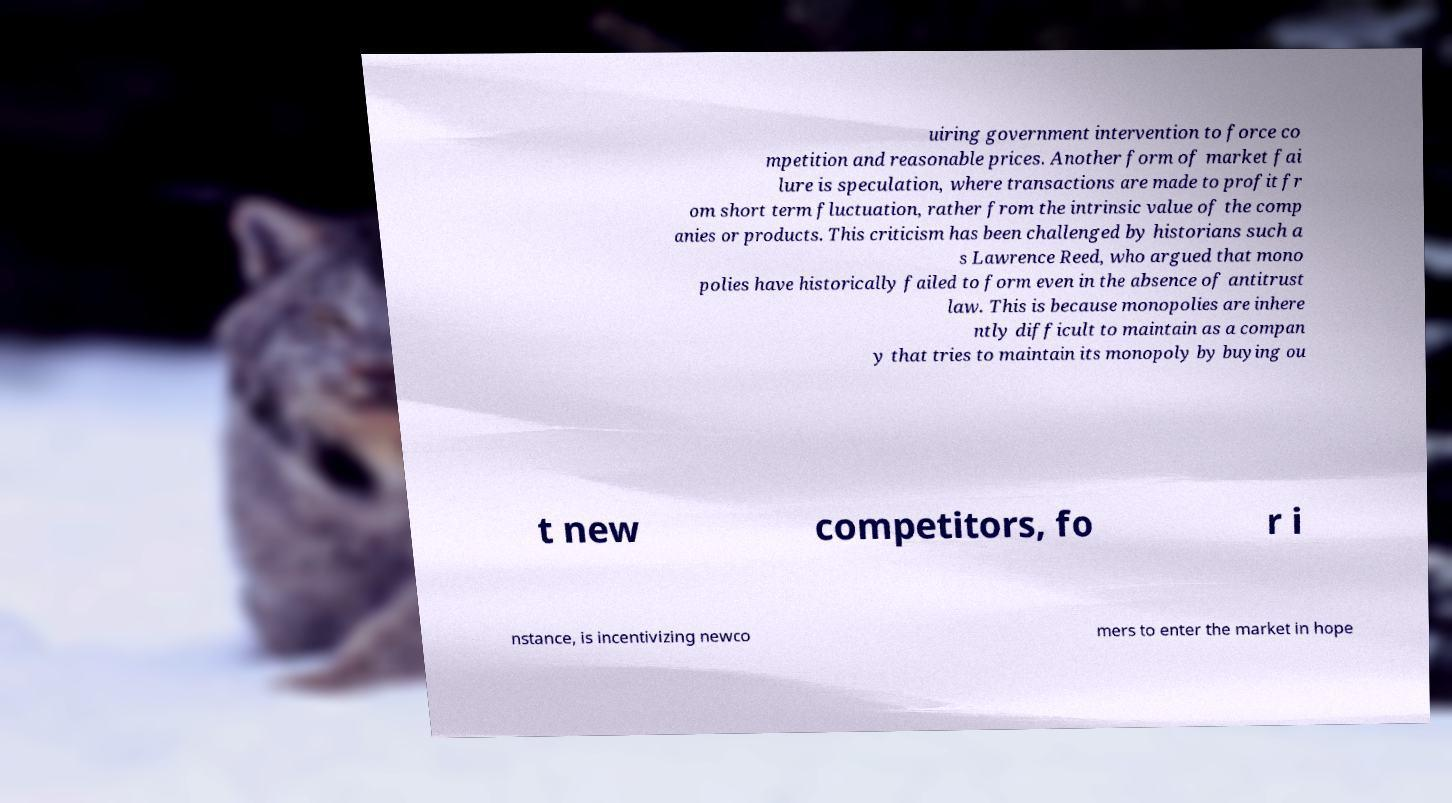Can you accurately transcribe the text from the provided image for me? uiring government intervention to force co mpetition and reasonable prices. Another form of market fai lure is speculation, where transactions are made to profit fr om short term fluctuation, rather from the intrinsic value of the comp anies or products. This criticism has been challenged by historians such a s Lawrence Reed, who argued that mono polies have historically failed to form even in the absence of antitrust law. This is because monopolies are inhere ntly difficult to maintain as a compan y that tries to maintain its monopoly by buying ou t new competitors, fo r i nstance, is incentivizing newco mers to enter the market in hope 